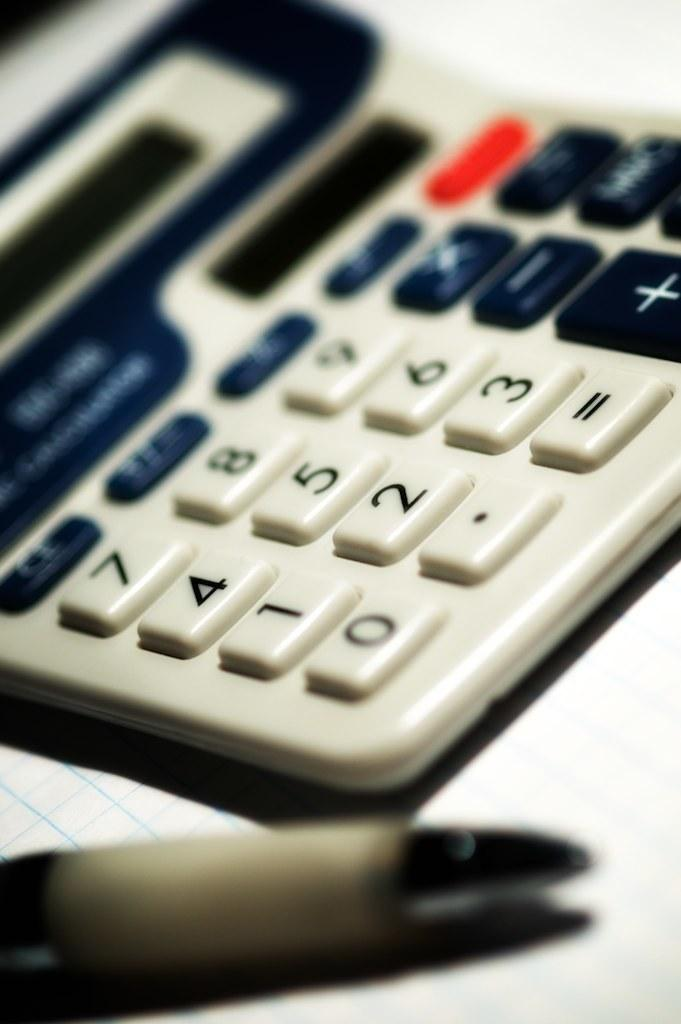<image>
Give a short and clear explanation of the subsequent image. A close up of a calculator with the number one visible. 